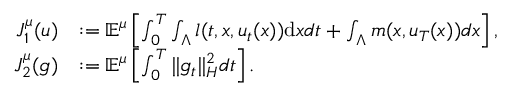<formula> <loc_0><loc_0><loc_500><loc_500>\begin{array} { r l } { J _ { 1 } ^ { \mu } ( u ) } & { \colon = { \mathbb { E } } ^ { \mu } \left [ \int _ { 0 } ^ { T } \int _ { \Lambda } l ( t , x , u _ { t } ( x ) ) d x d t + \int _ { \Lambda } m ( x , u _ { T } ( x ) ) d x \right ] , } \\ { J _ { 2 } ^ { \mu } ( \mathfrak { g } ) } & { \colon = { \mathbb { E } } ^ { \mu } \left [ \int _ { 0 } ^ { T } \| \mathfrak { g } _ { t } \| _ { H } ^ { 2 } d t \right ] . } \end{array}</formula> 